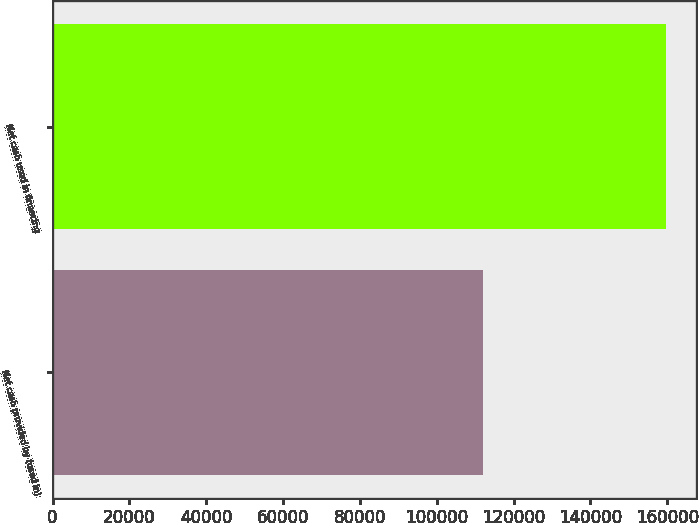Convert chart to OTSL. <chart><loc_0><loc_0><loc_500><loc_500><bar_chart><fcel>Net cash provided by (used in)<fcel>Net cash used in financing<nl><fcel>112027<fcel>159548<nl></chart> 